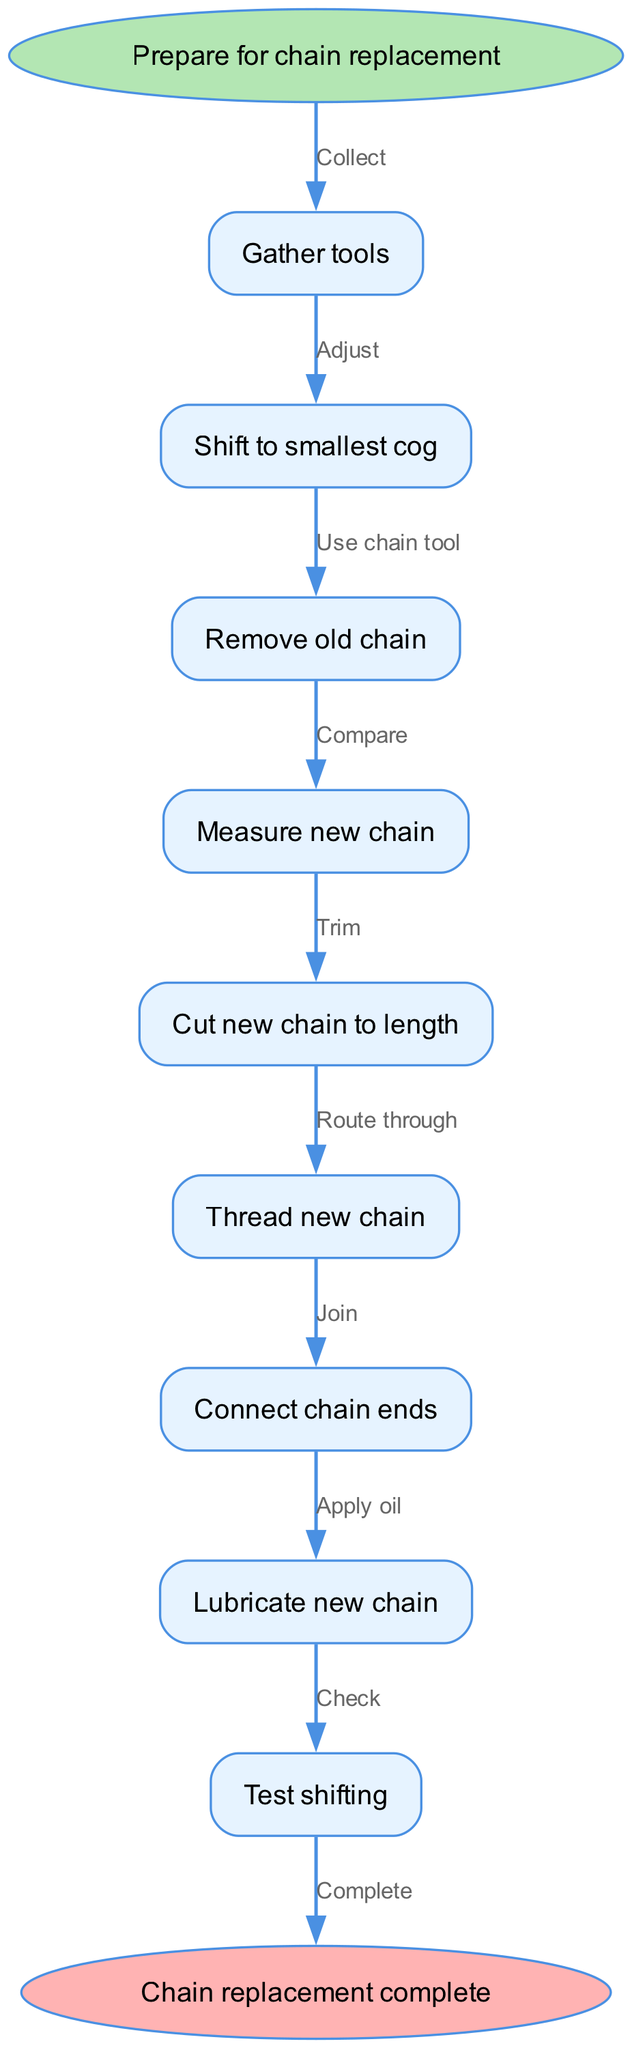What is the first step in the chain replacement process? The diagram indicates that the first step after "Prepare for chain replacement" is "Gather tools." This is evident as it's the first node connected to the starting point.
Answer: Gather tools How many steps are there in total for replacing the chain? By counting the nodes listed in the diagram's steps, there are a total of 9 steps from "Gather tools" to "Lubricate new chain."
Answer: 9 What action follows "Remove old chain"? Following "Remove old chain," the next action is "Measure new chain." This is deduced by looking at the edges connecting the nodes sequentially.
Answer: Measure new chain What do you do after "Cut new chain to length"? After "Cut new chain to length," you proceed to "Thread new chain." This is determined by examining the flow of the diagram, which connects each step in sequence.
Answer: Thread new chain What is the last action before the process is complete? The last action in the process before reaching the endpoint is "Test shifting." This can be identified as the final step in the series leading to "Chain replacement complete."
Answer: Test shifting Explain the relationship between "Shift to smallest cog" and "Remove old chain." "Shift to smallest cog" is a prerequisite step that occurs before "Remove old chain." This means you must complete the adjustment of the gears before you can proceed to remove the old chain, creating a direct flow relationship.
Answer: Adjust then use chain tool How is the new chain finally treated before completion? The new chain is "Lubricate new chain" before the completion of the process. This ensures that the chain operates smoothly and is indicated as the final preparation step prior to the last action.
Answer: Apply oil What must be compared before cutting the new chain? "Measure new chain" must be compared before cutting it. This step ensures that the new chain will fit appropriately on the bicycle after cutting.
Answer: Compare Which step must be completed before you can connect the chain ends? Before connecting the chain ends, you need to "Thread new chain." The diagram clearly shows that threading is an essential step that precedes connecting the ends of the chain.
Answer: Route through 